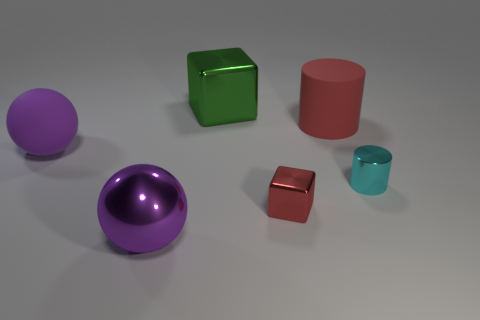Is there anything else that has the same material as the cyan cylinder?
Offer a terse response. Yes. What is the red block made of?
Your response must be concise. Metal. The matte thing behind the purple matte sphere that is on the left side of the big green metallic thing is what shape?
Make the answer very short. Cylinder. There is a big purple matte ball; are there any small red metallic objects in front of it?
Offer a very short reply. Yes. The tiny cylinder is what color?
Provide a succinct answer. Cyan. There is a large cube; does it have the same color as the small metallic thing on the left side of the cyan cylinder?
Provide a succinct answer. No. Are there any purple shiny objects of the same size as the cyan object?
Keep it short and to the point. No. The matte thing that is the same color as the small shiny cube is what size?
Give a very brief answer. Large. There is a tiny thing behind the red cube; what material is it?
Offer a very short reply. Metal. Are there the same number of big purple shiny spheres that are to the right of the purple shiny thing and tiny metal cylinders that are behind the red cylinder?
Provide a short and direct response. Yes. 